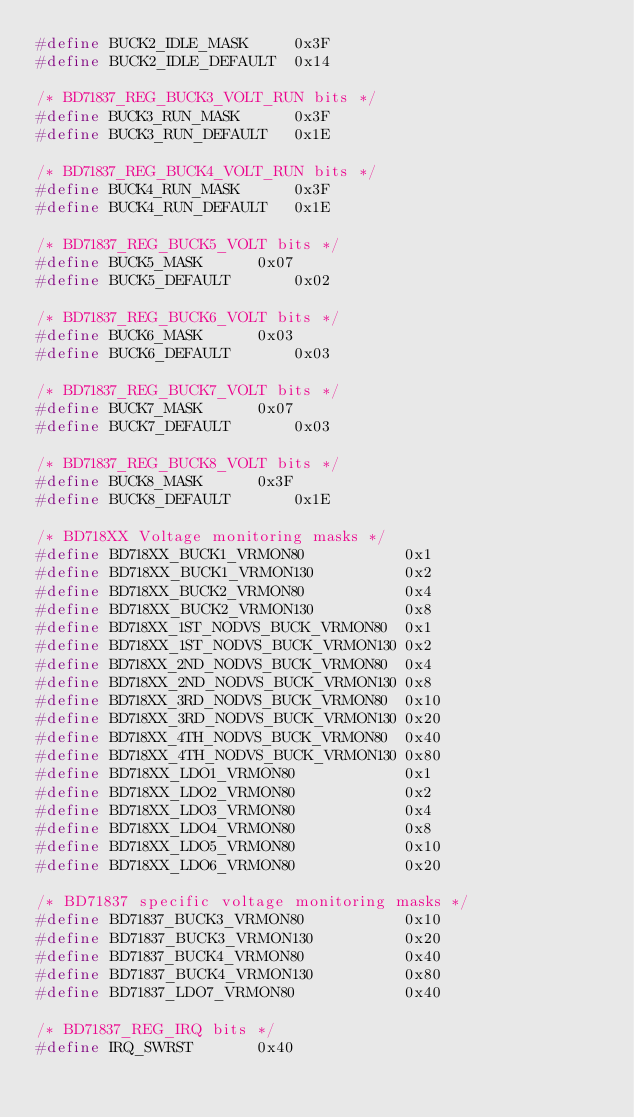<code> <loc_0><loc_0><loc_500><loc_500><_C_>#define BUCK2_IDLE_MASK		0x3F
#define BUCK2_IDLE_DEFAULT	0x14

/* BD71837_REG_BUCK3_VOLT_RUN bits */
#define BUCK3_RUN_MASK		0x3F
#define BUCK3_RUN_DEFAULT	0x1E

/* BD71837_REG_BUCK4_VOLT_RUN bits */
#define BUCK4_RUN_MASK		0x3F
#define BUCK4_RUN_DEFAULT	0x1E

/* BD71837_REG_BUCK5_VOLT bits */
#define BUCK5_MASK		0x07
#define BUCK5_DEFAULT		0x02

/* BD71837_REG_BUCK6_VOLT bits */
#define BUCK6_MASK		0x03
#define BUCK6_DEFAULT		0x03

/* BD71837_REG_BUCK7_VOLT bits */
#define BUCK7_MASK		0x07
#define BUCK7_DEFAULT		0x03

/* BD71837_REG_BUCK8_VOLT bits */
#define BUCK8_MASK		0x3F
#define BUCK8_DEFAULT		0x1E

/* BD718XX Voltage monitoring masks */
#define BD718XX_BUCK1_VRMON80           0x1
#define BD718XX_BUCK1_VRMON130          0x2
#define BD718XX_BUCK2_VRMON80           0x4
#define BD718XX_BUCK2_VRMON130          0x8
#define BD718XX_1ST_NODVS_BUCK_VRMON80  0x1
#define BD718XX_1ST_NODVS_BUCK_VRMON130 0x2
#define BD718XX_2ND_NODVS_BUCK_VRMON80  0x4
#define BD718XX_2ND_NODVS_BUCK_VRMON130 0x8
#define BD718XX_3RD_NODVS_BUCK_VRMON80  0x10
#define BD718XX_3RD_NODVS_BUCK_VRMON130 0x20
#define BD718XX_4TH_NODVS_BUCK_VRMON80  0x40
#define BD718XX_4TH_NODVS_BUCK_VRMON130 0x80
#define BD718XX_LDO1_VRMON80            0x1
#define BD718XX_LDO2_VRMON80            0x2
#define BD718XX_LDO3_VRMON80            0x4
#define BD718XX_LDO4_VRMON80            0x8
#define BD718XX_LDO5_VRMON80            0x10
#define BD718XX_LDO6_VRMON80            0x20

/* BD71837 specific voltage monitoring masks */
#define BD71837_BUCK3_VRMON80           0x10
#define BD71837_BUCK3_VRMON130          0x20
#define BD71837_BUCK4_VRMON80           0x40
#define BD71837_BUCK4_VRMON130          0x80
#define BD71837_LDO7_VRMON80            0x40

/* BD71837_REG_IRQ bits */
#define IRQ_SWRST		0x40</code> 